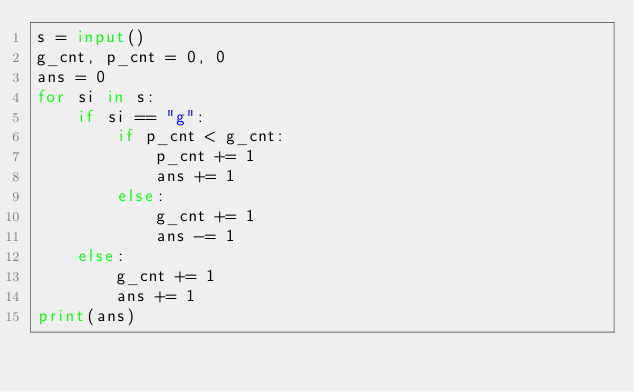<code> <loc_0><loc_0><loc_500><loc_500><_Python_>s = input()
g_cnt, p_cnt = 0, 0
ans = 0
for si in s:
    if si == "g":
        if p_cnt < g_cnt:
            p_cnt += 1
            ans += 1
        else:
            g_cnt += 1
            ans -= 1
    else:
        g_cnt += 1
        ans += 1
print(ans)
</code> 